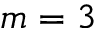<formula> <loc_0><loc_0><loc_500><loc_500>m = 3</formula> 